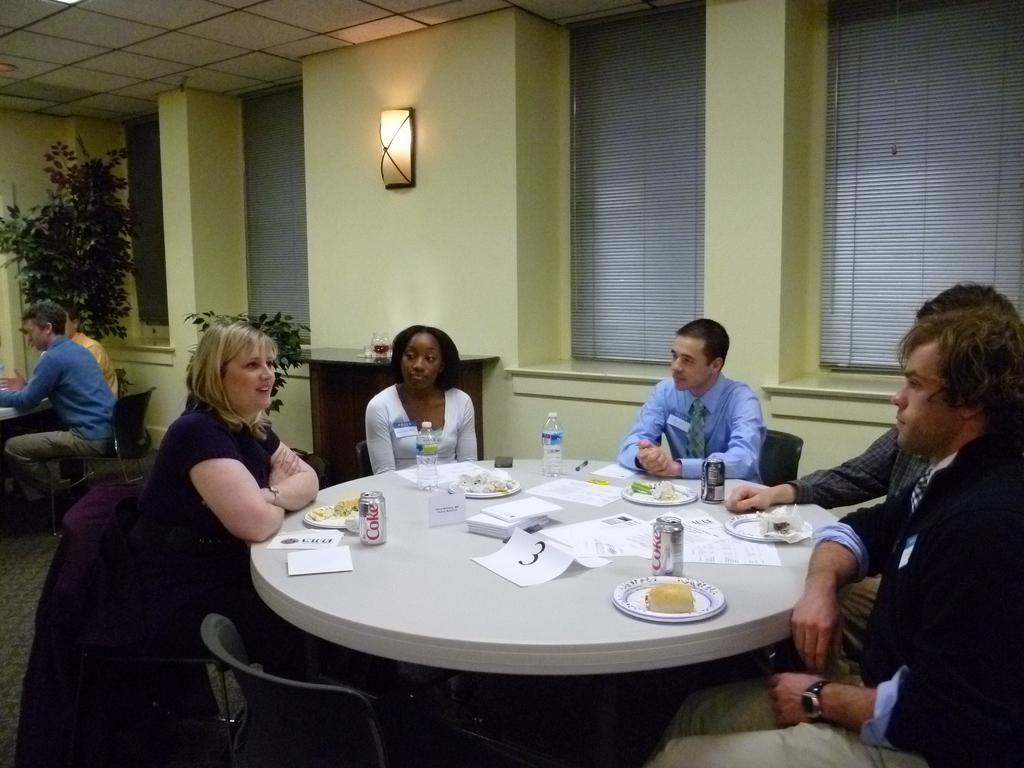Could you give a brief overview of what you see in this image? There are few persons sitting on the chairs. This is a table with plates of food,coke tins,water bottles and some papers on it. At background I can see a small table with some object on it. Here is a lamp attached to the wall. This looks like a houseplant. These are the windows which are closed. 